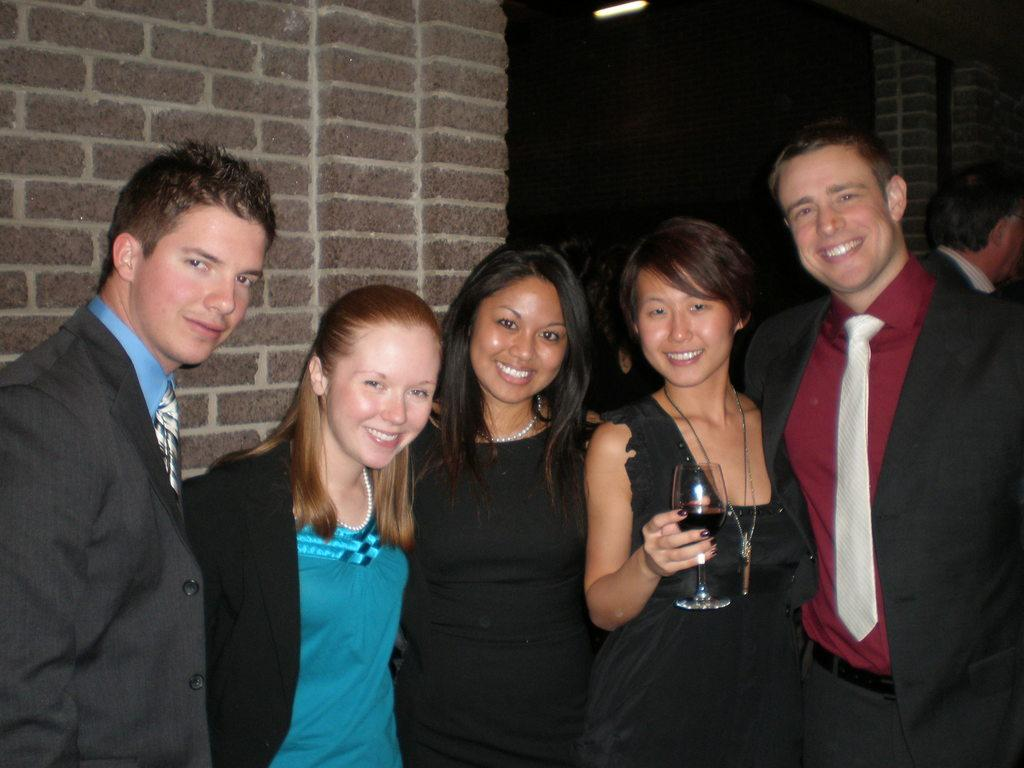How many people are in the image? There are five persons in the image. What are the persons in the image doing? The persons are posing for a camera and smiling. Can you describe the action of one of the persons? One person is holding a glass with their hand. What is visible in the background of the image? There is a wall and light in the background of the image. What type of insect can be seen crawling on the wall in the image? There is no insect visible on the wall in the image. How many screws are visible in the image? There are no screws present in the image. 